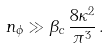<formula> <loc_0><loc_0><loc_500><loc_500>n _ { \phi } \gg \beta _ { c } \, \frac { 8 \kappa ^ { 2 } } { \pi ^ { 3 } } \, .</formula> 